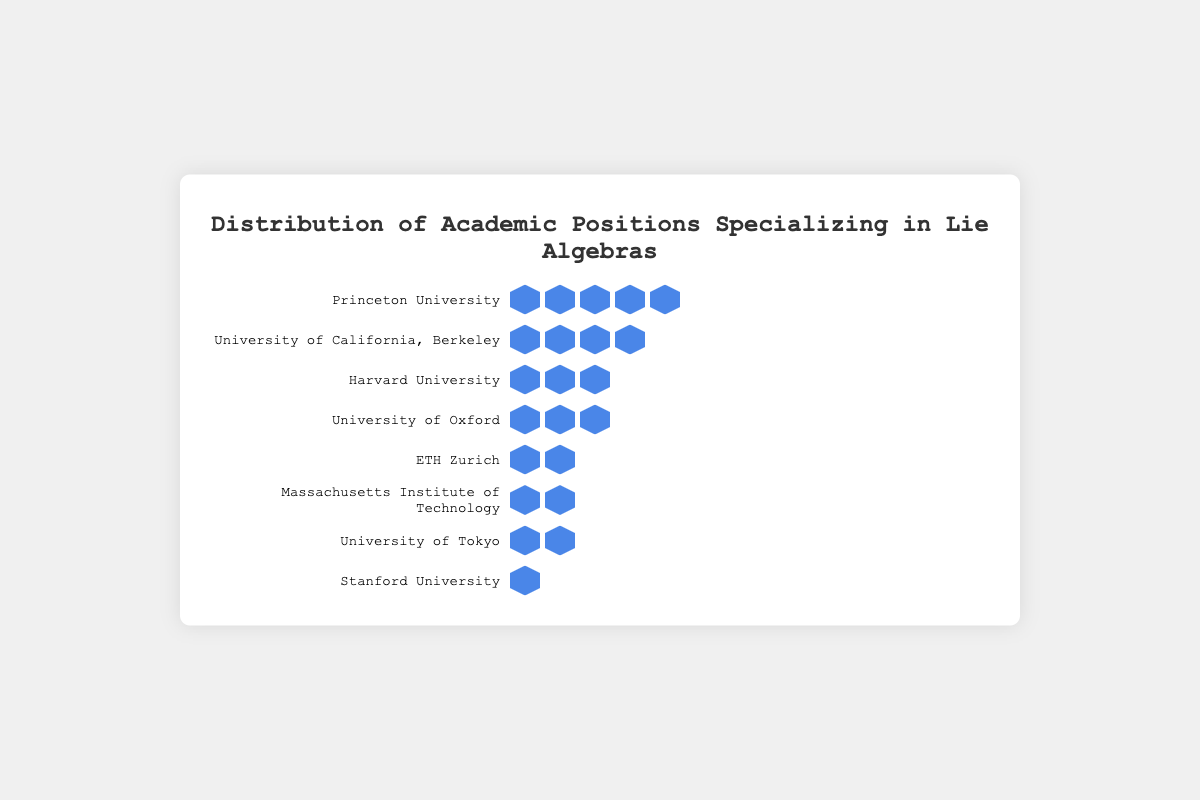How many universities have exactly 2 positions? To determine the number of universities with exactly 2 positions, look for rows with two position icons. From the chart, ETH Zurich, Massachusetts Institute of Technology, and University of Tokyo each have 2 positions. Thus, there are 3 universities with exactly 2 positions.
Answer: 3 Which university has the most academic positions specializing in Lie algebras? Identify the university with the highest number of position icons. Princeton University has the most positions with 5 icons.
Answer: Princeton University What is the total number of positions across all universities? Sum the positions from each university: 5 (Princeton) + 4 (UC Berkeley) + 3 (Harvard) + 3 (Oxford) + 2 (ETH Zurich) + 2 (MIT) + 2 (Tokyo) + 1 (Stanford) = 22
Answer: 22 Are there more universities with 3 or more positions or with fewer than 3 positions? Count the universities with 3 or more positions: Princeton, UC Berkeley, Harvard, and Oxford (4 universities). Count the universities with fewer than 3 positions: ETH Zurich, MIT, Tokyo, and Stanford (4 universities). Both counts are equal, so the number of universities with 3 or more positions is equal to those with fewer than 3 positions.
Answer: Equal Which universities have the same number of positions? Find universities with matching counts of position icons: Harvard University and University of Oxford each have 3 positions; ETH Zurich, Massachusetts Institute of Technology, and University of Tokyo each have 2 positions.
Answer: Harvard University and University of Oxford; ETH Zurich, Massachusetts Institute of Technology, and University of Tokyo What percentage of the total positions does Princeton University hold? First determine the total number of positions: 22. Princeton has 5 positions. The percentage is (5/22) * 100 ≈ 22.73%.
Answer: 22.73% Which university has the least number of positions? Identify the university with the fewest position icons. Stanford University has only 1 position.
Answer: Stanford University Calculate the average number of positions across all listed universities. Sum all positions (5 + 4 + 3 + 3 + 2 + 2 + 2 + 1 = 22) and divide by the number of universities (8). The average is 22 / 8 = 2.75.
Answer: 2.75 